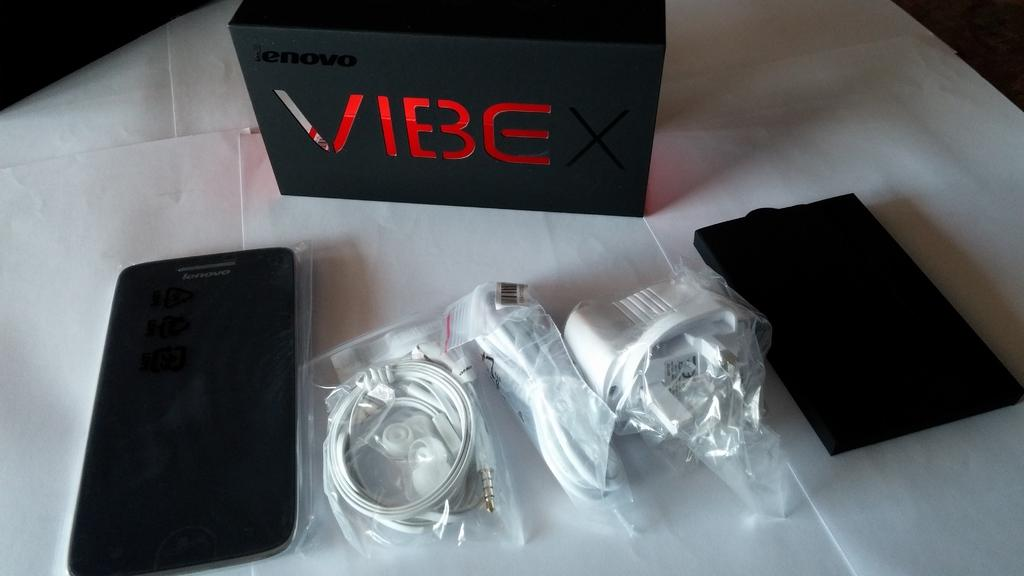<image>
Share a concise interpretation of the image provided. A new smartphone called a vibe with accessories such as headphones. 